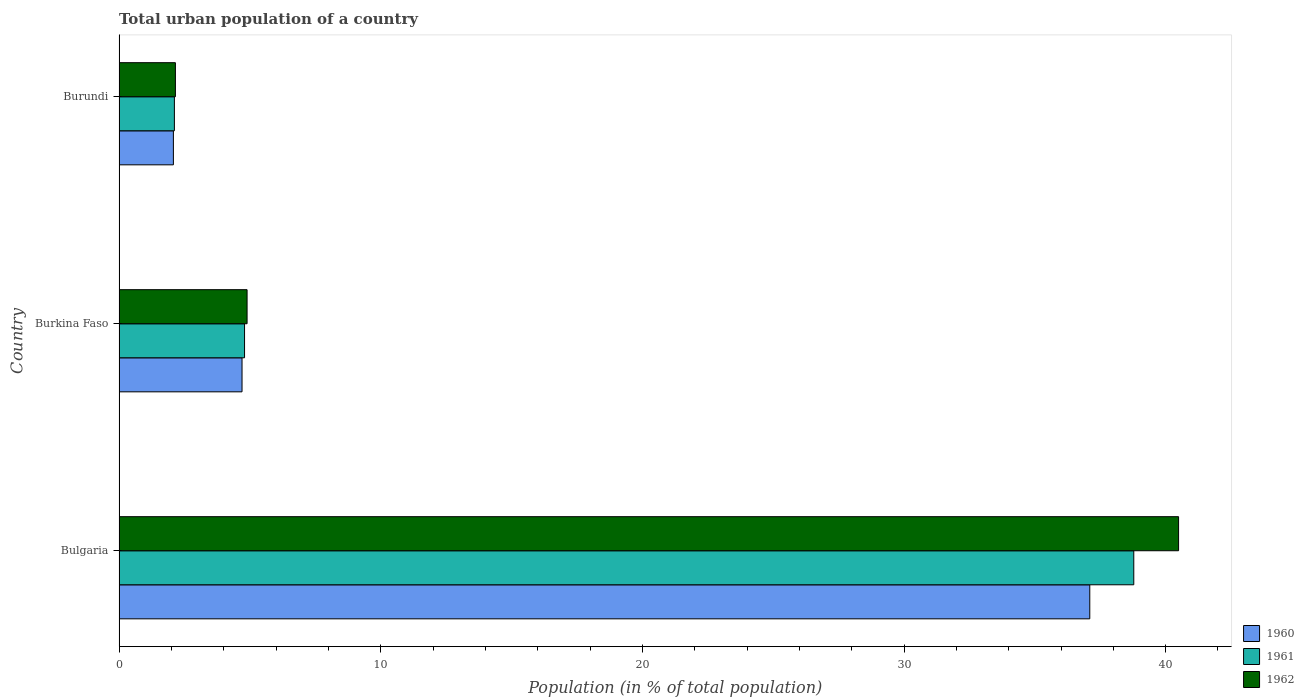How many different coloured bars are there?
Provide a short and direct response. 3. Are the number of bars on each tick of the Y-axis equal?
Your response must be concise. Yes. How many bars are there on the 2nd tick from the bottom?
Keep it short and to the point. 3. What is the label of the 2nd group of bars from the top?
Your response must be concise. Burkina Faso. In how many cases, is the number of bars for a given country not equal to the number of legend labels?
Your response must be concise. 0. What is the urban population in 1961 in Burundi?
Offer a terse response. 2.12. Across all countries, what is the maximum urban population in 1961?
Your answer should be very brief. 38.78. Across all countries, what is the minimum urban population in 1962?
Your answer should be very brief. 2.15. In which country was the urban population in 1962 maximum?
Give a very brief answer. Bulgaria. In which country was the urban population in 1962 minimum?
Offer a very short reply. Burundi. What is the total urban population in 1962 in the graph?
Offer a terse response. 47.54. What is the difference between the urban population in 1961 in Bulgaria and that in Burkina Faso?
Provide a short and direct response. 33.99. What is the difference between the urban population in 1960 in Burkina Faso and the urban population in 1962 in Bulgaria?
Your response must be concise. -35.79. What is the average urban population in 1961 per country?
Provide a short and direct response. 15.23. What is the difference between the urban population in 1962 and urban population in 1961 in Bulgaria?
Ensure brevity in your answer.  1.71. What is the ratio of the urban population in 1962 in Bulgaria to that in Burundi?
Offer a very short reply. 18.8. Is the urban population in 1961 in Bulgaria less than that in Burkina Faso?
Make the answer very short. No. Is the difference between the urban population in 1962 in Bulgaria and Burundi greater than the difference between the urban population in 1961 in Bulgaria and Burundi?
Offer a very short reply. Yes. What is the difference between the highest and the second highest urban population in 1960?
Provide a short and direct response. 32.4. What is the difference between the highest and the lowest urban population in 1961?
Your response must be concise. 36.67. What does the 1st bar from the top in Burkina Faso represents?
Offer a very short reply. 1962. How many bars are there?
Provide a short and direct response. 9. What is the difference between two consecutive major ticks on the X-axis?
Your response must be concise. 10. Are the values on the major ticks of X-axis written in scientific E-notation?
Your response must be concise. No. Does the graph contain any zero values?
Provide a short and direct response. No. What is the title of the graph?
Ensure brevity in your answer.  Total urban population of a country. What is the label or title of the X-axis?
Your answer should be compact. Population (in % of total population). What is the Population (in % of total population) in 1960 in Bulgaria?
Provide a succinct answer. 37.1. What is the Population (in % of total population) in 1961 in Bulgaria?
Your response must be concise. 38.78. What is the Population (in % of total population) of 1962 in Bulgaria?
Make the answer very short. 40.49. What is the Population (in % of total population) of 1961 in Burkina Faso?
Keep it short and to the point. 4.8. What is the Population (in % of total population) in 1962 in Burkina Faso?
Your answer should be very brief. 4.89. What is the Population (in % of total population) of 1960 in Burundi?
Your response must be concise. 2.08. What is the Population (in % of total population) of 1961 in Burundi?
Provide a succinct answer. 2.12. What is the Population (in % of total population) in 1962 in Burundi?
Provide a succinct answer. 2.15. Across all countries, what is the maximum Population (in % of total population) of 1960?
Your answer should be very brief. 37.1. Across all countries, what is the maximum Population (in % of total population) of 1961?
Make the answer very short. 38.78. Across all countries, what is the maximum Population (in % of total population) of 1962?
Your answer should be very brief. 40.49. Across all countries, what is the minimum Population (in % of total population) of 1960?
Offer a very short reply. 2.08. Across all countries, what is the minimum Population (in % of total population) in 1961?
Your answer should be very brief. 2.12. Across all countries, what is the minimum Population (in % of total population) in 1962?
Provide a short and direct response. 2.15. What is the total Population (in % of total population) of 1960 in the graph?
Give a very brief answer. 43.88. What is the total Population (in % of total population) in 1961 in the graph?
Make the answer very short. 45.69. What is the total Population (in % of total population) of 1962 in the graph?
Provide a short and direct response. 47.54. What is the difference between the Population (in % of total population) of 1960 in Bulgaria and that in Burkina Faso?
Provide a short and direct response. 32.4. What is the difference between the Population (in % of total population) of 1961 in Bulgaria and that in Burkina Faso?
Give a very brief answer. 33.99. What is the difference between the Population (in % of total population) in 1962 in Bulgaria and that in Burkina Faso?
Offer a very short reply. 35.6. What is the difference between the Population (in % of total population) in 1960 in Bulgaria and that in Burundi?
Offer a terse response. 35.02. What is the difference between the Population (in % of total population) in 1961 in Bulgaria and that in Burundi?
Ensure brevity in your answer.  36.67. What is the difference between the Population (in % of total population) of 1962 in Bulgaria and that in Burundi?
Keep it short and to the point. 38.34. What is the difference between the Population (in % of total population) of 1960 in Burkina Faso and that in Burundi?
Your answer should be very brief. 2.62. What is the difference between the Population (in % of total population) in 1961 in Burkina Faso and that in Burundi?
Provide a short and direct response. 2.68. What is the difference between the Population (in % of total population) in 1962 in Burkina Faso and that in Burundi?
Ensure brevity in your answer.  2.74. What is the difference between the Population (in % of total population) in 1960 in Bulgaria and the Population (in % of total population) in 1961 in Burkina Faso?
Keep it short and to the point. 32.3. What is the difference between the Population (in % of total population) in 1960 in Bulgaria and the Population (in % of total population) in 1962 in Burkina Faso?
Ensure brevity in your answer.  32.21. What is the difference between the Population (in % of total population) of 1961 in Bulgaria and the Population (in % of total population) of 1962 in Burkina Faso?
Keep it short and to the point. 33.89. What is the difference between the Population (in % of total population) of 1960 in Bulgaria and the Population (in % of total population) of 1961 in Burundi?
Make the answer very short. 34.98. What is the difference between the Population (in % of total population) of 1960 in Bulgaria and the Population (in % of total population) of 1962 in Burundi?
Provide a short and direct response. 34.95. What is the difference between the Population (in % of total population) of 1961 in Bulgaria and the Population (in % of total population) of 1962 in Burundi?
Ensure brevity in your answer.  36.63. What is the difference between the Population (in % of total population) of 1960 in Burkina Faso and the Population (in % of total population) of 1961 in Burundi?
Offer a very short reply. 2.58. What is the difference between the Population (in % of total population) of 1960 in Burkina Faso and the Population (in % of total population) of 1962 in Burundi?
Provide a short and direct response. 2.55. What is the difference between the Population (in % of total population) in 1961 in Burkina Faso and the Population (in % of total population) in 1962 in Burundi?
Provide a short and direct response. 2.64. What is the average Population (in % of total population) of 1960 per country?
Your response must be concise. 14.63. What is the average Population (in % of total population) in 1961 per country?
Make the answer very short. 15.23. What is the average Population (in % of total population) in 1962 per country?
Keep it short and to the point. 15.85. What is the difference between the Population (in % of total population) in 1960 and Population (in % of total population) in 1961 in Bulgaria?
Offer a very short reply. -1.68. What is the difference between the Population (in % of total population) in 1960 and Population (in % of total population) in 1962 in Bulgaria?
Offer a very short reply. -3.39. What is the difference between the Population (in % of total population) of 1961 and Population (in % of total population) of 1962 in Bulgaria?
Give a very brief answer. -1.71. What is the difference between the Population (in % of total population) in 1960 and Population (in % of total population) in 1961 in Burkina Faso?
Give a very brief answer. -0.1. What is the difference between the Population (in % of total population) in 1960 and Population (in % of total population) in 1962 in Burkina Faso?
Your response must be concise. -0.19. What is the difference between the Population (in % of total population) in 1961 and Population (in % of total population) in 1962 in Burkina Faso?
Make the answer very short. -0.1. What is the difference between the Population (in % of total population) in 1960 and Population (in % of total population) in 1961 in Burundi?
Offer a very short reply. -0.04. What is the difference between the Population (in % of total population) in 1960 and Population (in % of total population) in 1962 in Burundi?
Offer a terse response. -0.08. What is the difference between the Population (in % of total population) of 1961 and Population (in % of total population) of 1962 in Burundi?
Ensure brevity in your answer.  -0.04. What is the ratio of the Population (in % of total population) of 1960 in Bulgaria to that in Burkina Faso?
Your answer should be compact. 7.89. What is the ratio of the Population (in % of total population) of 1961 in Bulgaria to that in Burkina Faso?
Offer a very short reply. 8.09. What is the ratio of the Population (in % of total population) in 1962 in Bulgaria to that in Burkina Faso?
Give a very brief answer. 8.28. What is the ratio of the Population (in % of total population) in 1960 in Bulgaria to that in Burundi?
Offer a very short reply. 17.86. What is the ratio of the Population (in % of total population) of 1961 in Bulgaria to that in Burundi?
Your answer should be compact. 18.34. What is the ratio of the Population (in % of total population) in 1962 in Bulgaria to that in Burundi?
Keep it short and to the point. 18.8. What is the ratio of the Population (in % of total population) in 1960 in Burkina Faso to that in Burundi?
Your answer should be compact. 2.26. What is the ratio of the Population (in % of total population) of 1961 in Burkina Faso to that in Burundi?
Provide a short and direct response. 2.27. What is the ratio of the Population (in % of total population) in 1962 in Burkina Faso to that in Burundi?
Your response must be concise. 2.27. What is the difference between the highest and the second highest Population (in % of total population) of 1960?
Ensure brevity in your answer.  32.4. What is the difference between the highest and the second highest Population (in % of total population) in 1961?
Your response must be concise. 33.99. What is the difference between the highest and the second highest Population (in % of total population) of 1962?
Make the answer very short. 35.6. What is the difference between the highest and the lowest Population (in % of total population) in 1960?
Your response must be concise. 35.02. What is the difference between the highest and the lowest Population (in % of total population) in 1961?
Offer a terse response. 36.67. What is the difference between the highest and the lowest Population (in % of total population) of 1962?
Your response must be concise. 38.34. 